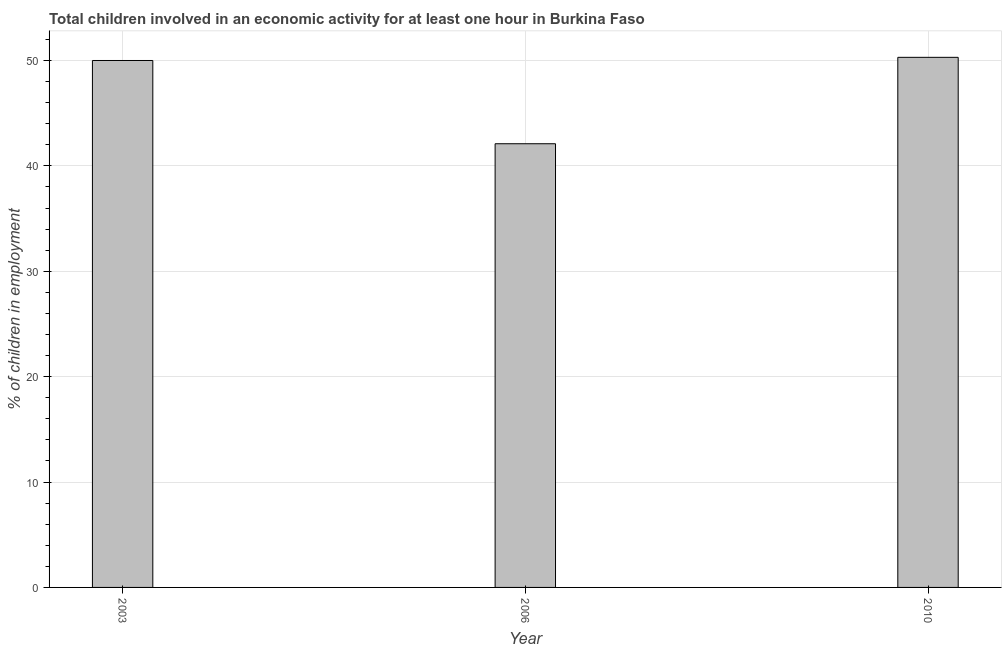What is the title of the graph?
Your answer should be compact. Total children involved in an economic activity for at least one hour in Burkina Faso. What is the label or title of the Y-axis?
Offer a terse response. % of children in employment. What is the percentage of children in employment in 2010?
Provide a short and direct response. 50.3. Across all years, what is the maximum percentage of children in employment?
Your answer should be compact. 50.3. Across all years, what is the minimum percentage of children in employment?
Make the answer very short. 42.1. What is the sum of the percentage of children in employment?
Keep it short and to the point. 142.4. What is the difference between the percentage of children in employment in 2006 and 2010?
Keep it short and to the point. -8.2. What is the average percentage of children in employment per year?
Your answer should be compact. 47.47. What is the median percentage of children in employment?
Provide a short and direct response. 50. In how many years, is the percentage of children in employment greater than 18 %?
Make the answer very short. 3. Do a majority of the years between 2003 and 2006 (inclusive) have percentage of children in employment greater than 4 %?
Give a very brief answer. Yes. What is the ratio of the percentage of children in employment in 2003 to that in 2006?
Offer a very short reply. 1.19. What is the difference between the highest and the second highest percentage of children in employment?
Make the answer very short. 0.3. Is the sum of the percentage of children in employment in 2006 and 2010 greater than the maximum percentage of children in employment across all years?
Make the answer very short. Yes. What is the difference between the highest and the lowest percentage of children in employment?
Your answer should be very brief. 8.2. In how many years, is the percentage of children in employment greater than the average percentage of children in employment taken over all years?
Make the answer very short. 2. What is the difference between two consecutive major ticks on the Y-axis?
Your answer should be compact. 10. What is the % of children in employment of 2006?
Offer a very short reply. 42.1. What is the % of children in employment of 2010?
Give a very brief answer. 50.3. What is the difference between the % of children in employment in 2003 and 2006?
Provide a succinct answer. 7.9. What is the ratio of the % of children in employment in 2003 to that in 2006?
Give a very brief answer. 1.19. What is the ratio of the % of children in employment in 2006 to that in 2010?
Ensure brevity in your answer.  0.84. 